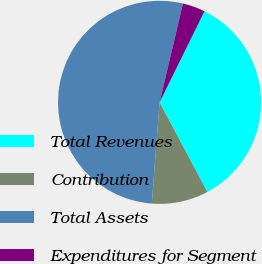Convert chart. <chart><loc_0><loc_0><loc_500><loc_500><pie_chart><fcel>Total Revenues<fcel>Contribution<fcel>Total Assets<fcel>Expenditures for Segment<nl><fcel>34.91%<fcel>9.01%<fcel>52.47%<fcel>3.6%<nl></chart> 